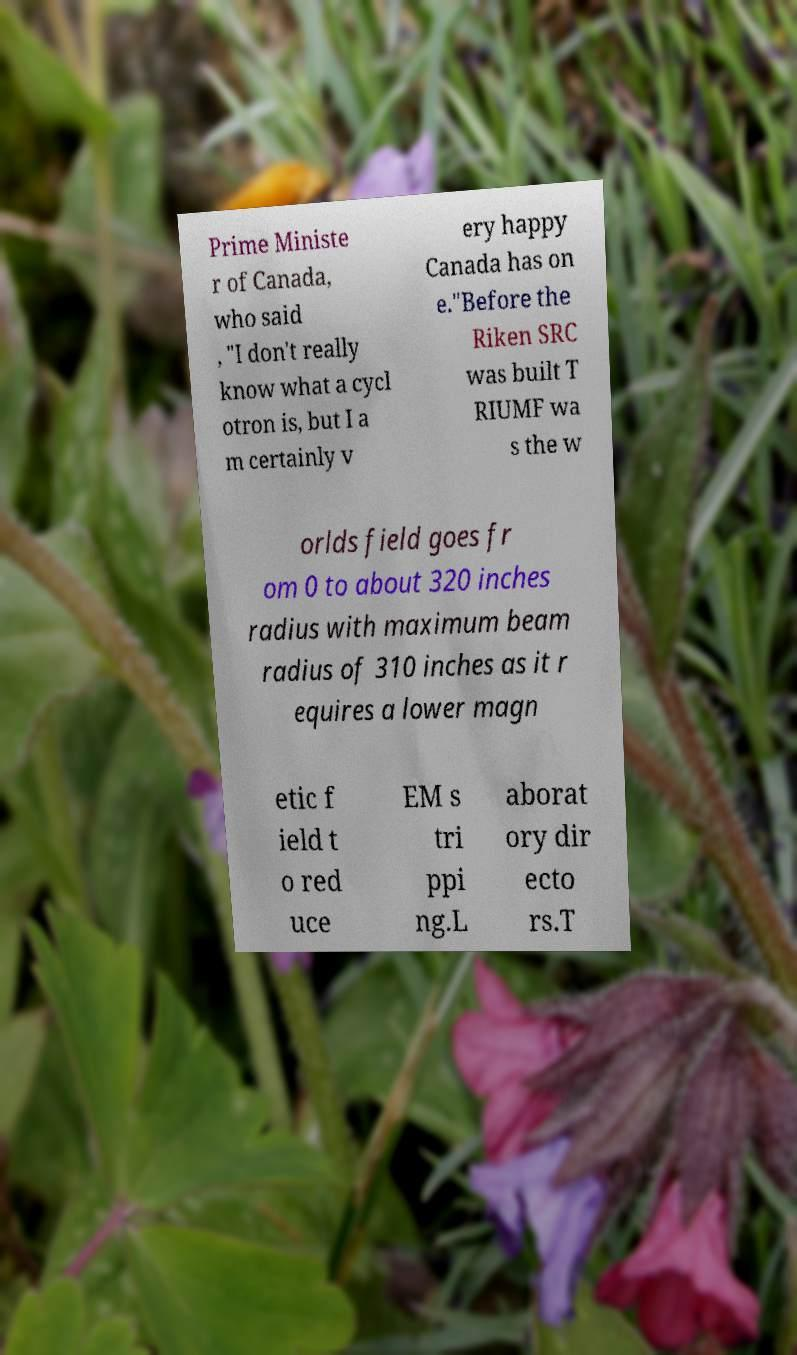Can you read and provide the text displayed in the image?This photo seems to have some interesting text. Can you extract and type it out for me? Prime Ministe r of Canada, who said , "I don't really know what a cycl otron is, but I a m certainly v ery happy Canada has on e."Before the Riken SRC was built T RIUMF wa s the w orlds field goes fr om 0 to about 320 inches radius with maximum beam radius of 310 inches as it r equires a lower magn etic f ield t o red uce EM s tri ppi ng.L aborat ory dir ecto rs.T 